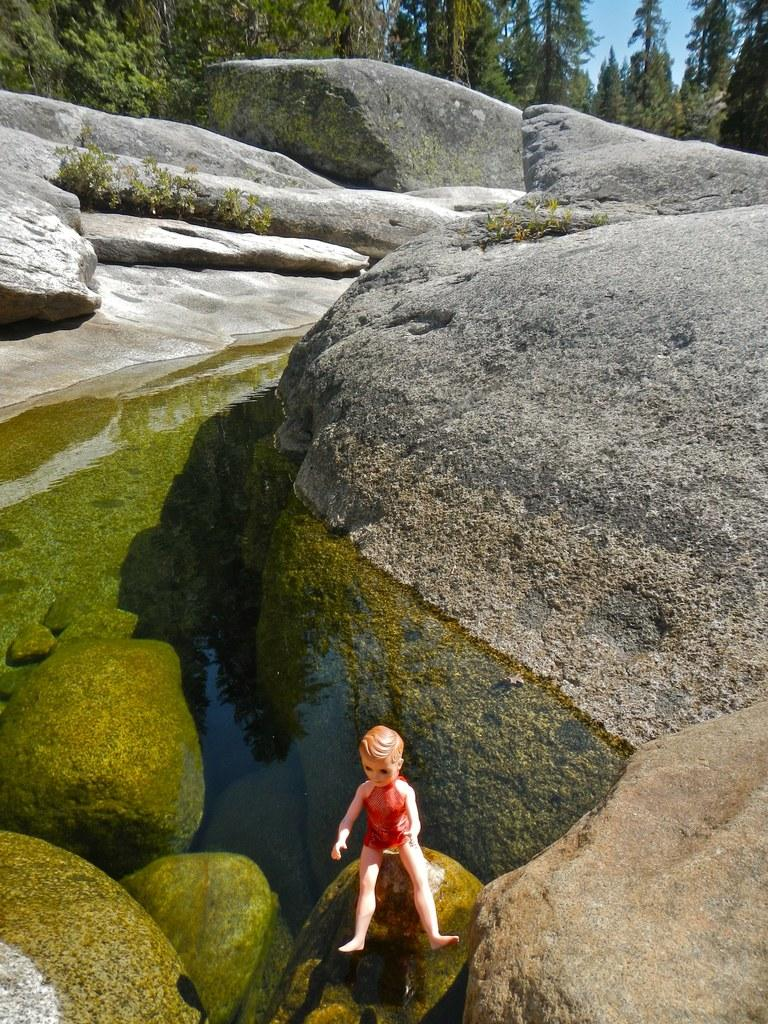What is the main subject of the image? There is a toy of a boy in the image. Where is the toy located? The toy is sitting on a rock. What can be seen behind the toy? There is water visible behind the toy. What other elements are present in the background of the image? There are rocks, trees, and the sky visible in the background of the image. What type of bucket is the toy carrying in the image? There is no bucket present in the image; the toy is sitting on a rock with no visible objects in its hands. 